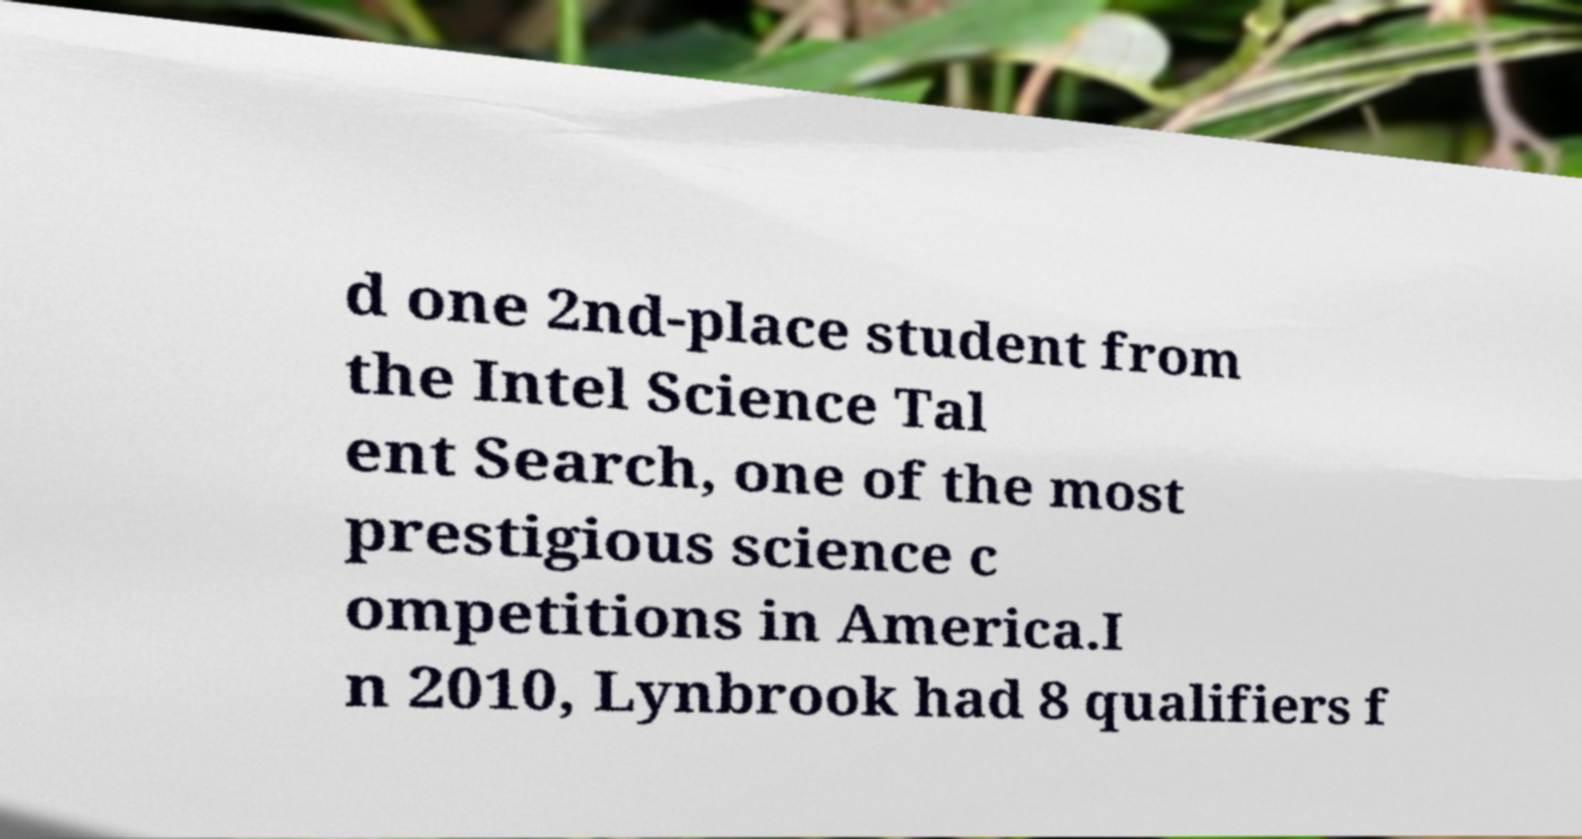Please read and relay the text visible in this image. What does it say? d one 2nd-place student from the Intel Science Tal ent Search, one of the most prestigious science c ompetitions in America.I n 2010, Lynbrook had 8 qualifiers f 